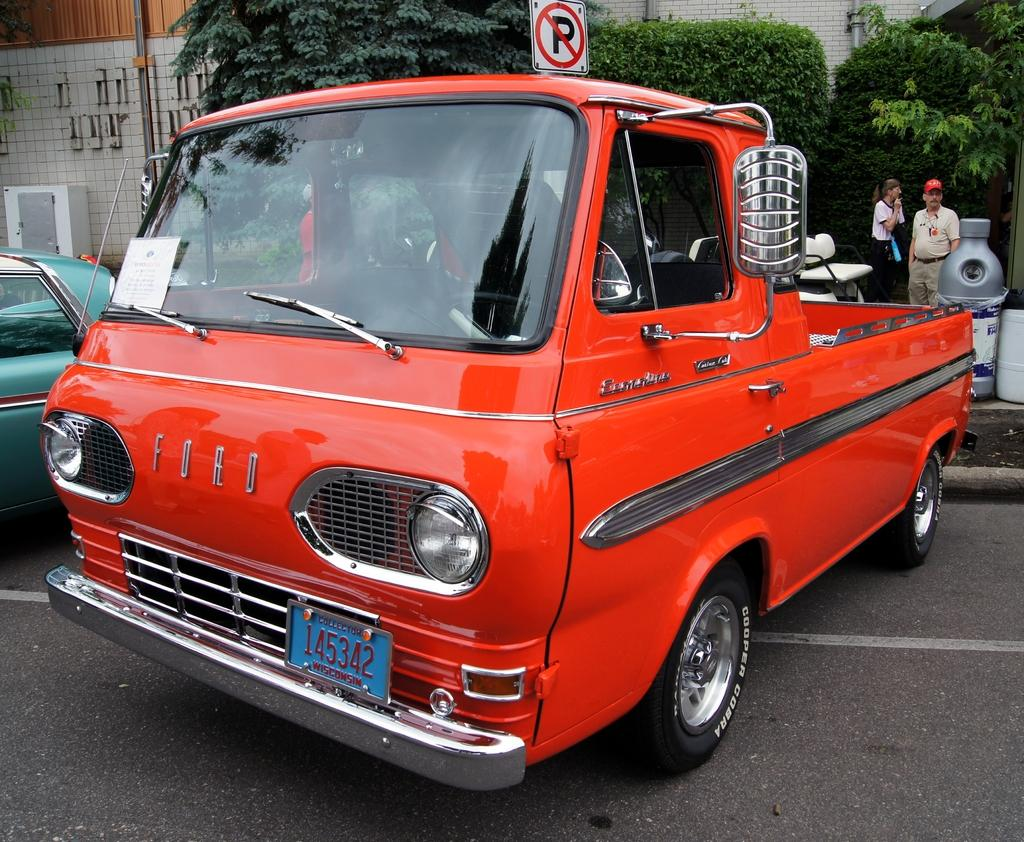<image>
Relay a brief, clear account of the picture shown. A bright orange Ford van that has been modified into a truck. 